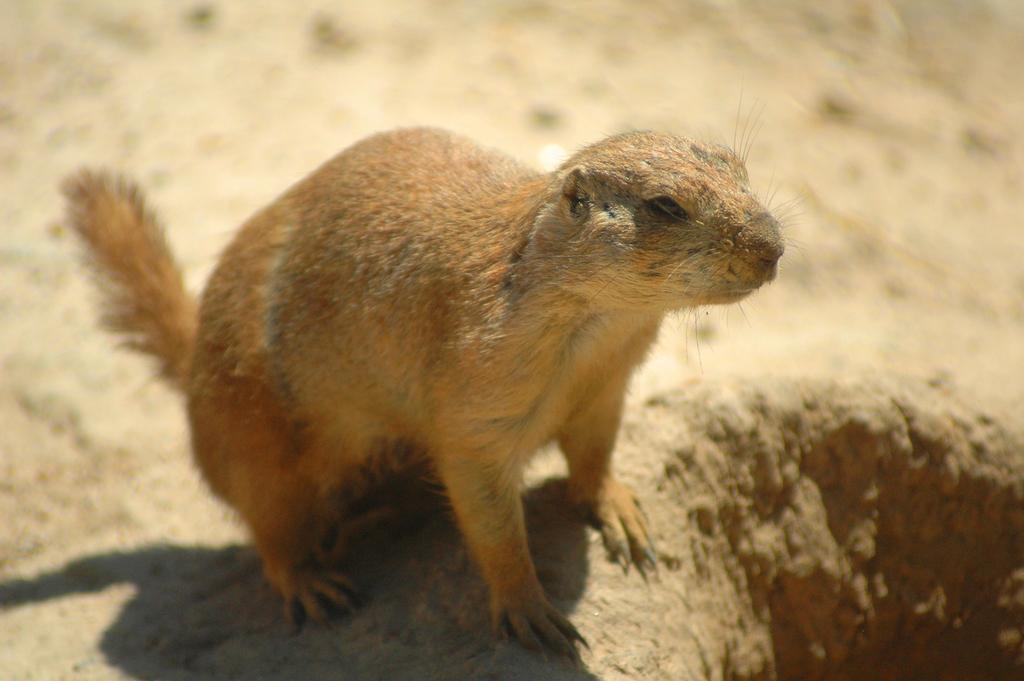Describe this image in one or two sentences. This picture is clicked outside. In the center there is an animal standing on the ground. The background of the image is blurry. 